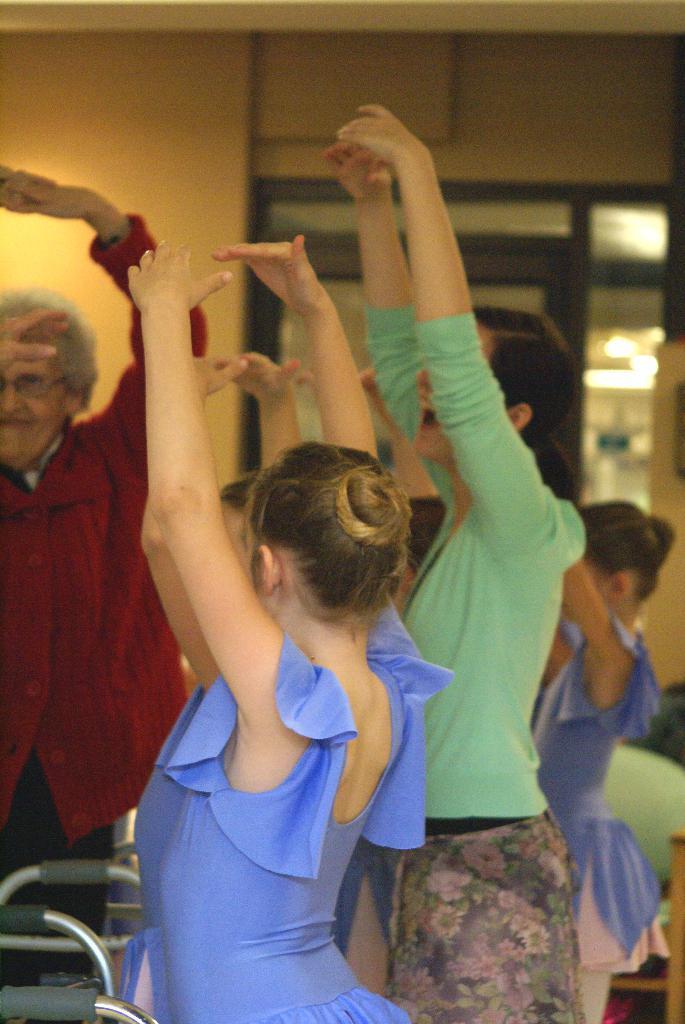Describe this image in one or two sentences. In this image we can see a few people. Here we can see the people raised their hands and looks like they are smiling. 